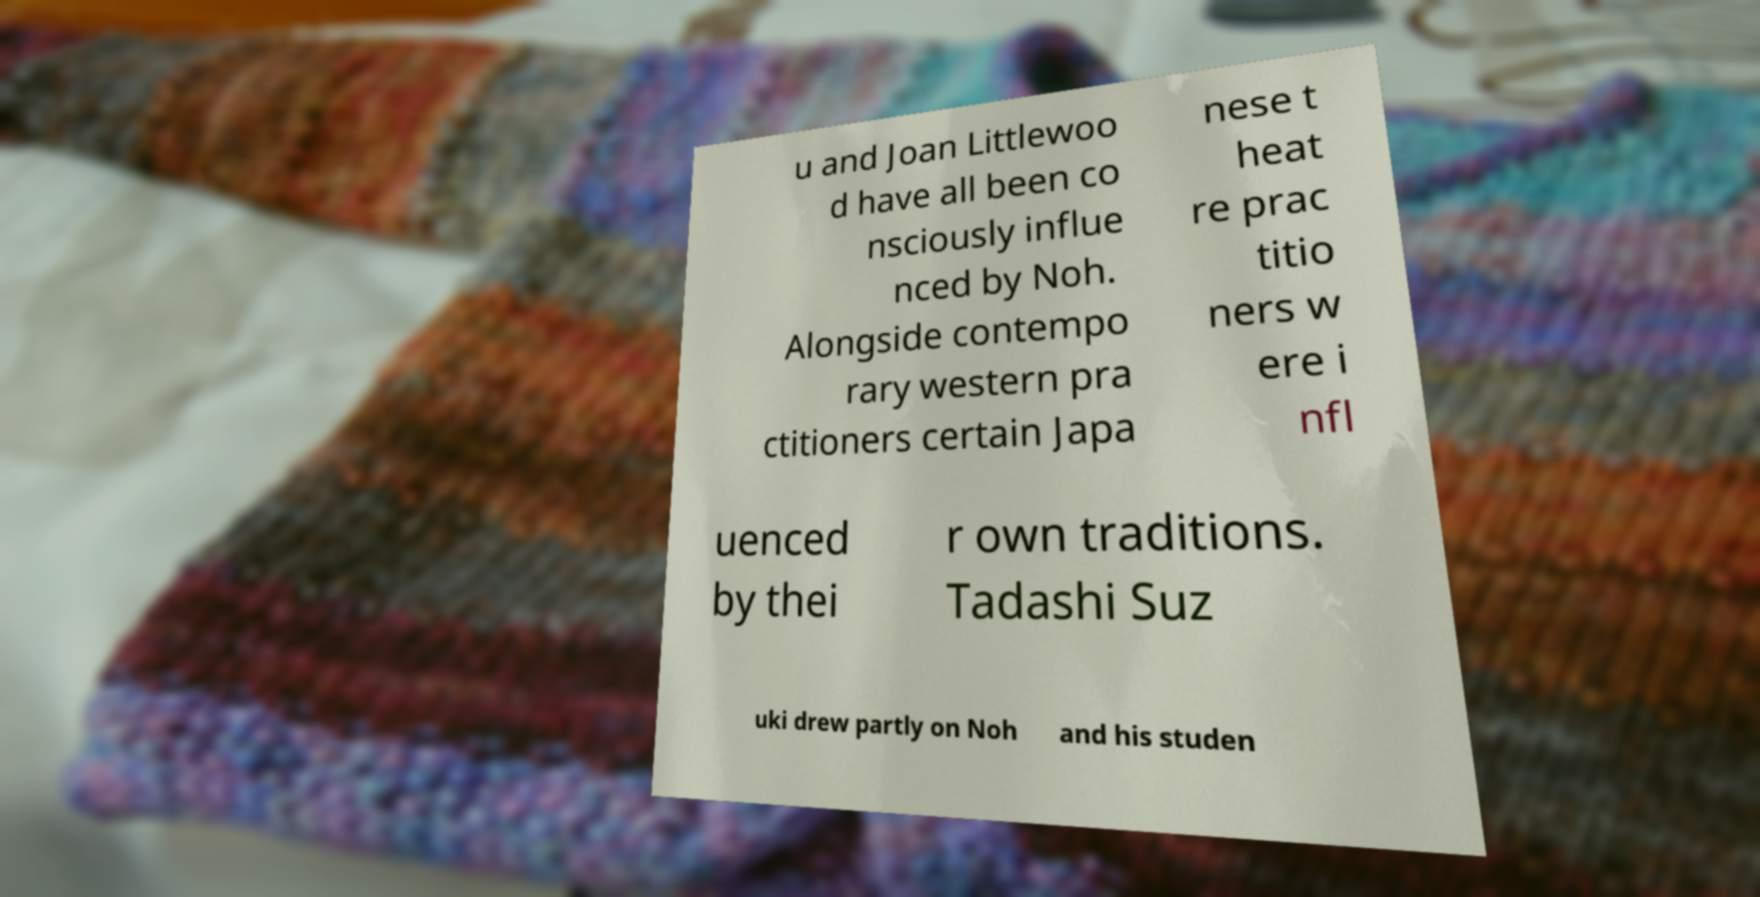Can you read and provide the text displayed in the image?This photo seems to have some interesting text. Can you extract and type it out for me? u and Joan Littlewoo d have all been co nsciously influe nced by Noh. Alongside contempo rary western pra ctitioners certain Japa nese t heat re prac titio ners w ere i nfl uenced by thei r own traditions. Tadashi Suz uki drew partly on Noh and his studen 